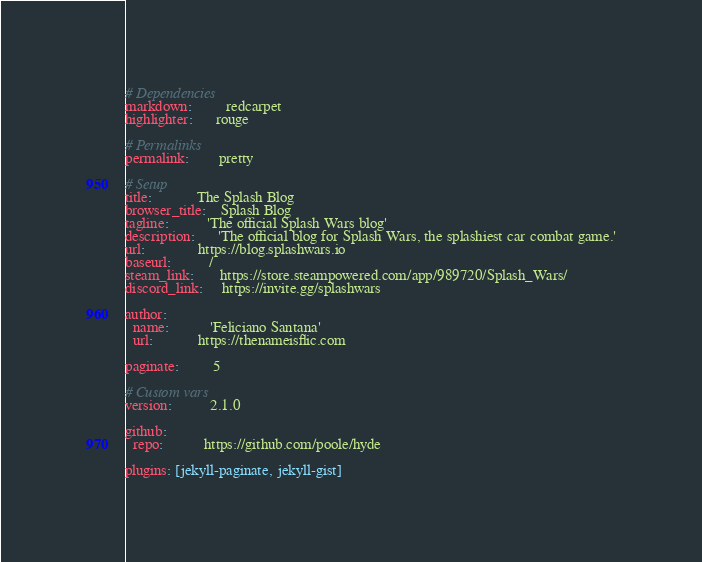Convert code to text. <code><loc_0><loc_0><loc_500><loc_500><_YAML_># Dependencies
markdown:         redcarpet
highlighter:      rouge

# Permalinks
permalink:        pretty

# Setup
title:            The Splash Blog
browser_title:    Splash Blog
tagline:          'The official Splash Wars blog'
description:      'The official blog for Splash Wars, the splashiest car combat game.'
url:              https://blog.splashwars.io
baseurl:          /
steam_link:       https://store.steampowered.com/app/989720/Splash_Wars/
discord_link:     https://invite.gg/splashwars

author:
  name:           'Feliciano Santana'
  url:            https://thenameisflic.com

paginate:         5

# Custom vars
version:          2.1.0

github:
  repo:           https://github.com/poole/hyde

plugins: [jekyll-paginate, jekyll-gist]
</code> 